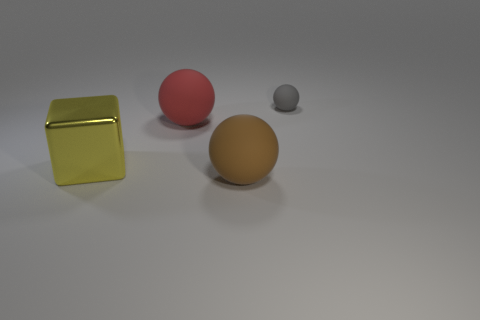There is a big matte thing in front of the block; does it have the same color as the large matte ball behind the yellow metal object?
Ensure brevity in your answer.  No. What size is the gray matte object that is the same shape as the red thing?
Offer a very short reply. Small. Is the material of the big sphere behind the large shiny thing the same as the large object on the left side of the red sphere?
Make the answer very short. No. What number of metallic objects are small yellow cubes or gray things?
Give a very brief answer. 0. What is the large object right of the large ball to the left of the rubber sphere that is in front of the large red matte thing made of?
Offer a very short reply. Rubber. Is the shape of the large matte thing that is in front of the large cube the same as the thing that is behind the red object?
Offer a terse response. Yes. What color is the large matte sphere that is left of the big matte ball that is in front of the large yellow thing?
Keep it short and to the point. Red. How many cubes are large metal things or red things?
Offer a very short reply. 1. There is a rubber thing behind the large thing behind the metallic thing; how many big red matte objects are on the right side of it?
Provide a short and direct response. 0. Is there a tiny thing that has the same material as the big red thing?
Ensure brevity in your answer.  Yes. 